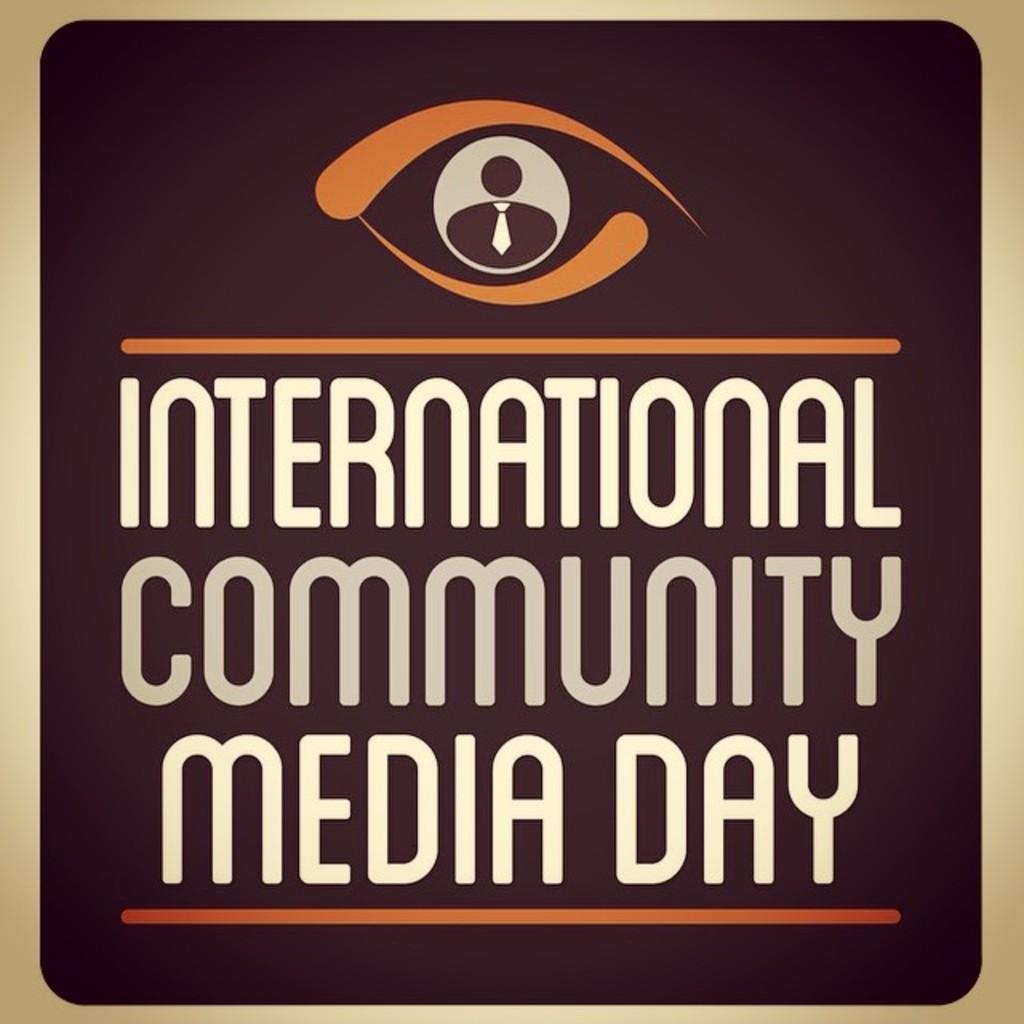<image>
Give a short and clear explanation of the subsequent image. A sign for international community media day features a person wearing a tie. 